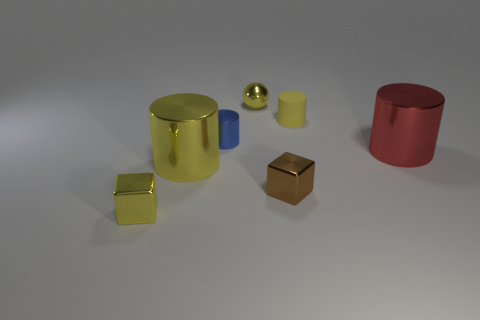There is a metal object that is behind the small blue cylinder; what shape is it?
Offer a terse response. Sphere. How many other blue objects are the same shape as the tiny matte object?
Your response must be concise. 1. There is a metallic object that is behind the rubber cylinder; is it the same color as the tiny cylinder to the right of the shiny sphere?
Your response must be concise. Yes. What number of things are either big cyan matte spheres or brown objects?
Your answer should be compact. 1. How many red cylinders have the same material as the red thing?
Provide a succinct answer. 0. Is the number of balls less than the number of gray matte cylinders?
Offer a very short reply. No. Is the block that is left of the big yellow metal object made of the same material as the sphere?
Offer a very short reply. Yes. How many cylinders are tiny blue objects or large metallic objects?
Your answer should be compact. 3. The thing that is both behind the tiny brown shiny block and to the left of the tiny blue object has what shape?
Your response must be concise. Cylinder. What is the color of the big metal cylinder that is to the left of the yellow metallic thing that is behind the large cylinder to the right of the brown metallic object?
Your answer should be very brief. Yellow. 